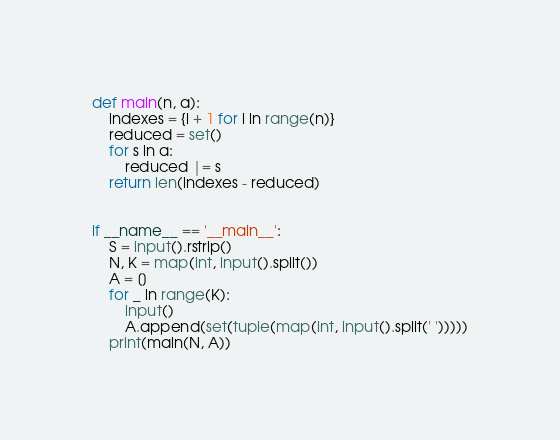Convert code to text. <code><loc_0><loc_0><loc_500><loc_500><_Python_>def main(n, a):
    indexes = {i + 1 for i in range(n)}
    reduced = set()
    for s in a:
        reduced |= s
    return len(indexes - reduced)


if __name__ == '__main__':
    S = input().rstrip()
    N, K = map(int, input().split())
    A = []
    for _ in range(K):
        input()
        A.append(set(tuple(map(int, input().split(' ')))))
    print(main(N, A))
</code> 